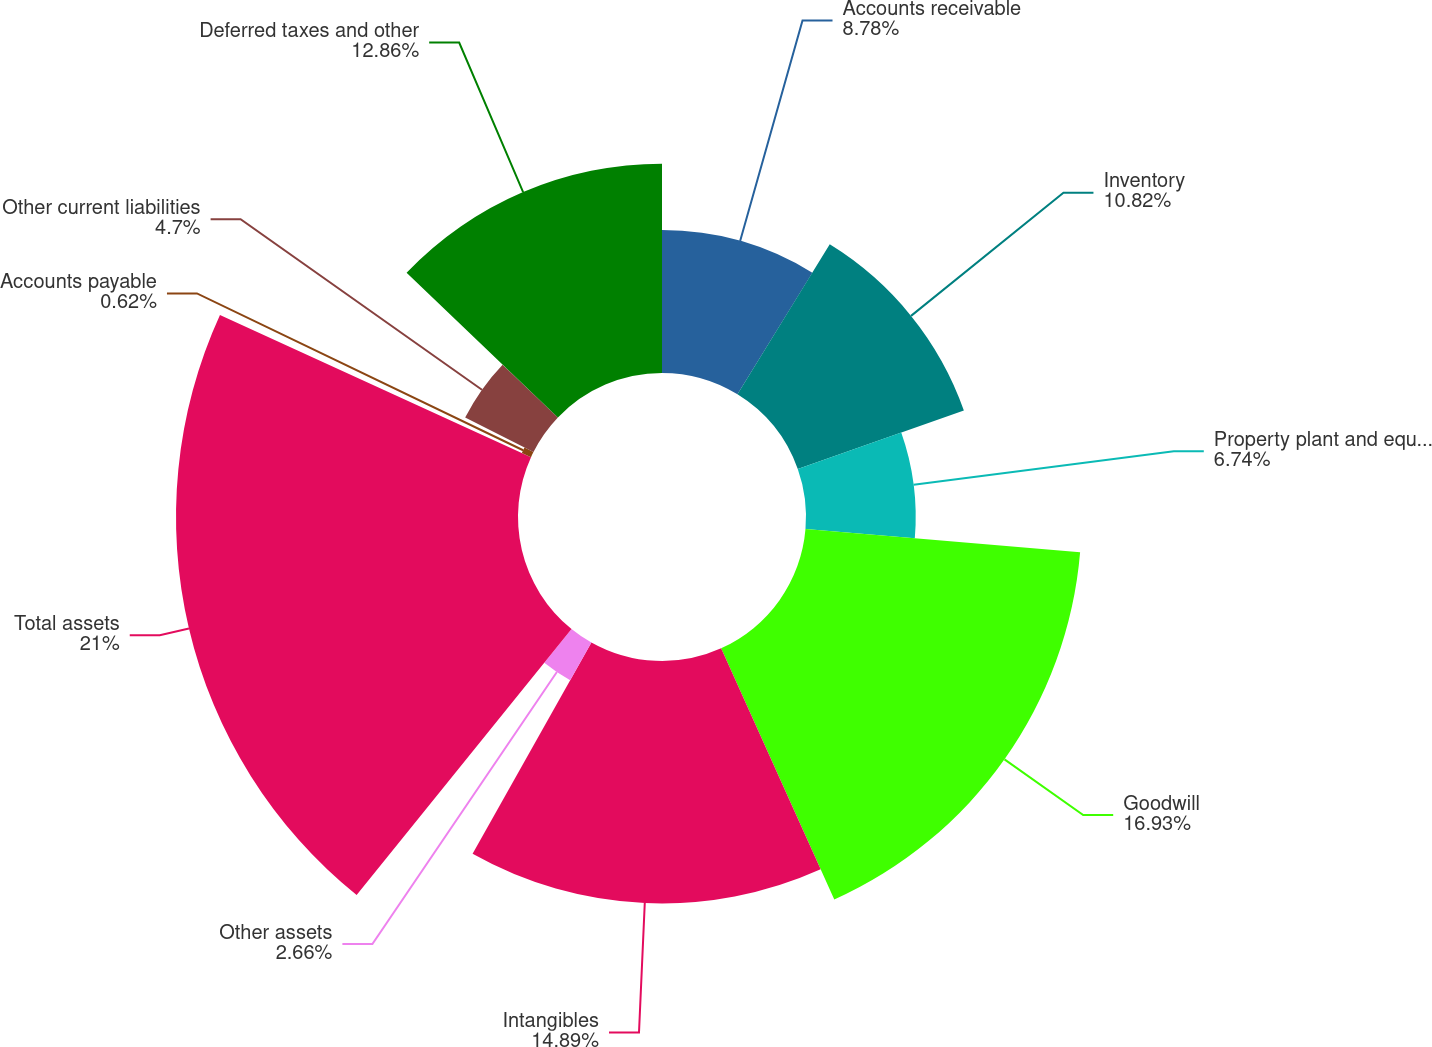Convert chart to OTSL. <chart><loc_0><loc_0><loc_500><loc_500><pie_chart><fcel>Accounts receivable<fcel>Inventory<fcel>Property plant and equipment<fcel>Goodwill<fcel>Intangibles<fcel>Other assets<fcel>Total assets<fcel>Accounts payable<fcel>Other current liabilities<fcel>Deferred taxes and other<nl><fcel>8.78%<fcel>10.82%<fcel>6.74%<fcel>16.93%<fcel>14.89%<fcel>2.66%<fcel>21.01%<fcel>0.62%<fcel>4.7%<fcel>12.86%<nl></chart> 